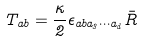Convert formula to latex. <formula><loc_0><loc_0><loc_500><loc_500>T _ { a b } = \frac { \kappa } { 2 } \epsilon _ { a b a _ { 3 } \cdots a _ { d } } \bar { R }</formula> 